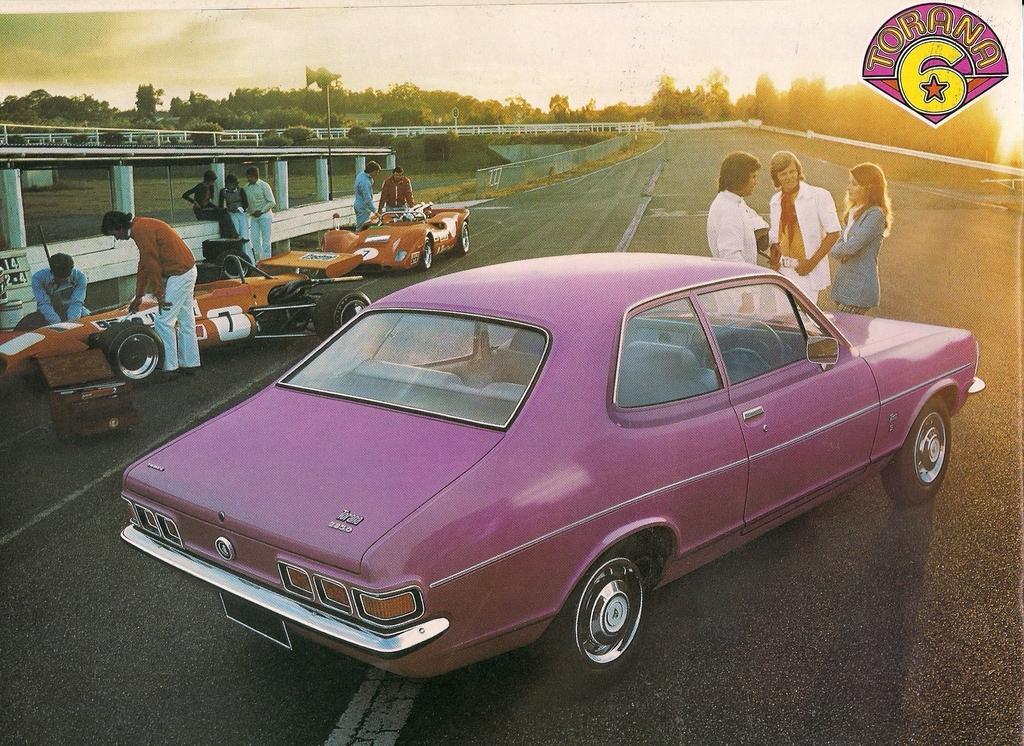In one or two sentences, can you explain what this image depicts? In this picture we can see vehicles, people on the road and in the background we can see trees, sky, in the top right we can see a logo. 